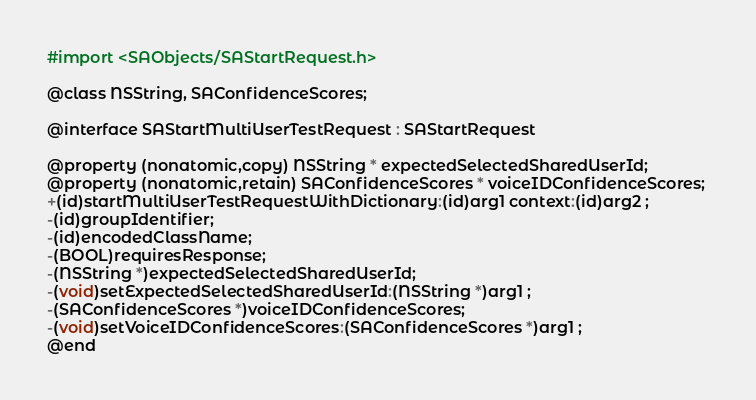Convert code to text. <code><loc_0><loc_0><loc_500><loc_500><_C_>#import <SAObjects/SAStartRequest.h>

@class NSString, SAConfidenceScores;

@interface SAStartMultiUserTestRequest : SAStartRequest

@property (nonatomic,copy) NSString * expectedSelectedSharedUserId; 
@property (nonatomic,retain) SAConfidenceScores * voiceIDConfidenceScores; 
+(id)startMultiUserTestRequestWithDictionary:(id)arg1 context:(id)arg2 ;
-(id)groupIdentifier;
-(id)encodedClassName;
-(BOOL)requiresResponse;
-(NSString *)expectedSelectedSharedUserId;
-(void)setExpectedSelectedSharedUserId:(NSString *)arg1 ;
-(SAConfidenceScores *)voiceIDConfidenceScores;
-(void)setVoiceIDConfidenceScores:(SAConfidenceScores *)arg1 ;
@end

</code> 